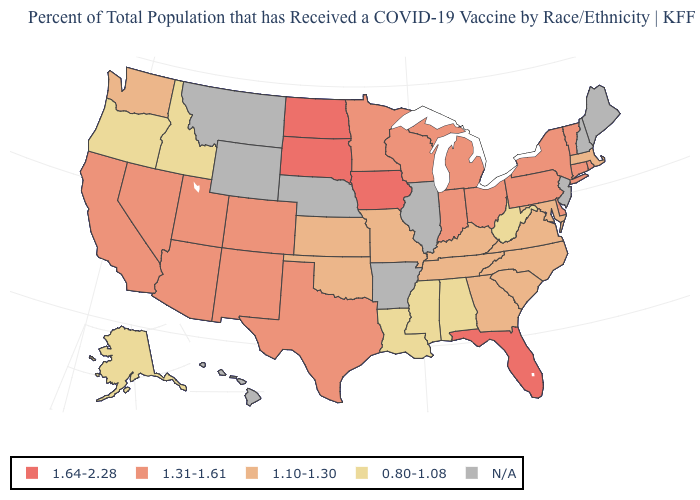Which states have the lowest value in the West?
Write a very short answer. Alaska, Idaho, Oregon. What is the value of Connecticut?
Keep it brief. 1.31-1.61. Is the legend a continuous bar?
Write a very short answer. No. Name the states that have a value in the range 1.10-1.30?
Short answer required. Georgia, Kansas, Kentucky, Maryland, Massachusetts, Missouri, North Carolina, Oklahoma, South Carolina, Tennessee, Virginia, Washington. What is the value of Alaska?
Write a very short answer. 0.80-1.08. What is the highest value in the USA?
Answer briefly. 1.64-2.28. Name the states that have a value in the range 1.64-2.28?
Be succinct. Florida, Iowa, North Dakota, South Dakota. Name the states that have a value in the range N/A?
Short answer required. Arkansas, Hawaii, Illinois, Maine, Montana, Nebraska, New Hampshire, New Jersey, Wyoming. What is the value of Maine?
Be succinct. N/A. Name the states that have a value in the range 1.10-1.30?
Give a very brief answer. Georgia, Kansas, Kentucky, Maryland, Massachusetts, Missouri, North Carolina, Oklahoma, South Carolina, Tennessee, Virginia, Washington. What is the lowest value in states that border Minnesota?
Give a very brief answer. 1.31-1.61. Name the states that have a value in the range 1.64-2.28?
Keep it brief. Florida, Iowa, North Dakota, South Dakota. Does the first symbol in the legend represent the smallest category?
Quick response, please. No. Among the states that border Rhode Island , which have the highest value?
Be succinct. Connecticut. Among the states that border Oklahoma , does Kansas have the highest value?
Answer briefly. No. 